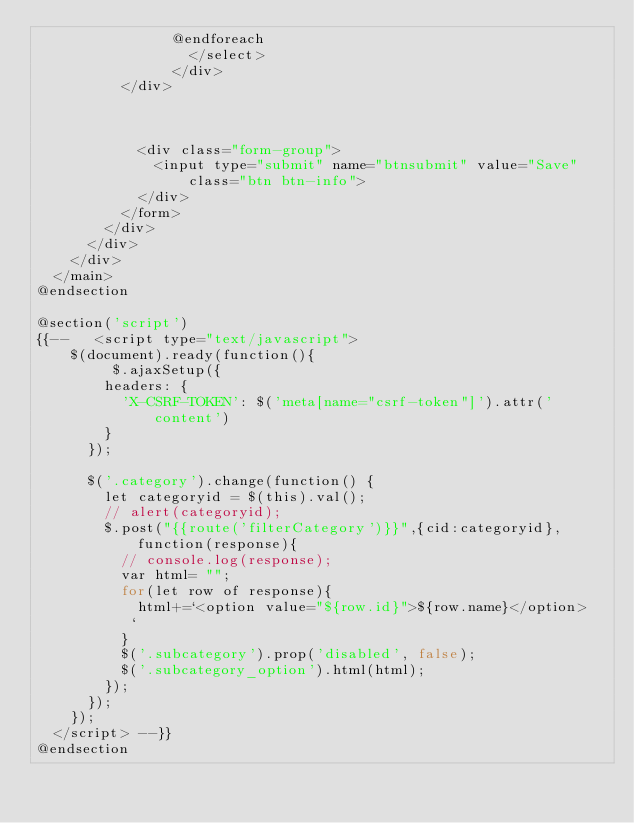Convert code to text. <code><loc_0><loc_0><loc_500><loc_500><_PHP_>                @endforeach
                  </select>
                </div>
          </div>



            <div class="form-group">
              <input type="submit" name="btnsubmit" value="Save" class="btn btn-info">
            </div>
          </form>
        </div>
      </div>
    </div>
  </main>
@endsection

@section('script')
{{--   <script type="text/javascript">
    $(document).ready(function(){
         $.ajaxSetup({
        headers: {
          'X-CSRF-TOKEN': $('meta[name="csrf-token"]').attr('content')
        }
      });

      $('.category').change(function() {
        let categoryid = $(this).val();
        // alert(categoryid);
        $.post("{{route('filterCategory')}}",{cid:categoryid}, function(response){
          // console.log(response);
          var html= "";
          for(let row of response){
            html+=`<option value="${row.id}">${row.name}</option>
           `
          }
          $('.subcategory').prop('disabled', false);
          $('.subcategory_option').html(html);
        });
      });
    });
  </script> --}}
@endsection</code> 